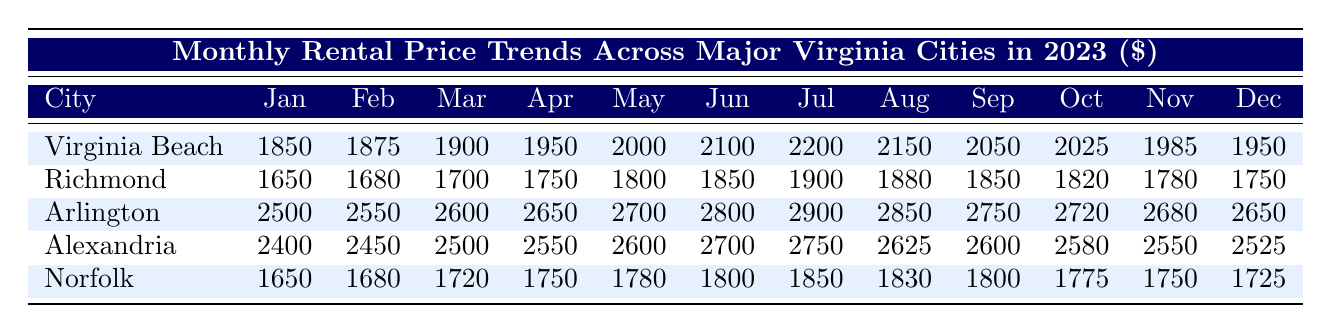What is the monthly rental price in Virginia Beach for June? The table provides the annual monthly rental prices for each city. In the row for Virginia Beach and under the column for June, the rental price is clearly listed as 2100.
Answer: 2100 What was the highest monthly rental price recorded in Arlington? In the Arlington row, the maximum monthly rental price is observed in July, where the value is listed as 2900.
Answer: 2900 Which city had the lowest rental price in January? Looking at the first column (January), the rental prices are 1850 for Virginia Beach, 1650 for Richmond, 2500 for Arlington, 2400 for Alexandria, and 1650 for Norfolk. The lowest price is 1650, which belongs to both Richmond and Norfolk.
Answer: 1650 What is the average monthly rental price for Norfolk over the year? To find the average, sum all the months for Norfolk: (1650 + 1680 + 1720 + 1750 + 1780 + 1800 + 1850 + 1830 + 1800 + 1775 + 1750 + 1725) = 20900. Dividing by the number of months (12), gives 20900/12 = 1741.67, which rounds to approximately 1742.
Answer: 1742 Is the rental price in Richmond higher than that in Virginia Beach in any month? By comparing the monthly figures, Richmond starts at 1650 and increases to a maximum of 1900 in July, while Virginia Beach starts at 1850 and climbs to a peak of 2200 in July. Richmond's price is lower than Virginia Beach's in all months.
Answer: No In which month did Alexandria's rental price reach its peak? Reviewing the Alexandria row, the price reaches its maximum of 2750 in July.
Answer: July What was the difference in rental prices between the highest month for Virginia Beach and the lowest month for Richmond? The highest rental price for Virginia Beach is 2200 in July, while the lowest for Richmond is 1650 in January. The difference is 2200 - 1650 = 550.
Answer: 550 How many months had a rental price greater than 2500 in Arlington? By counting those months in the Arlington row, the prices exceed 2500 in June (2800), July (2900), August (2850), September (2750), October (2720), November (2680), and December (2650). Total count is 7 months.
Answer: 7 Does the rental price trend in Virginia Beach show a clear upward pattern throughout the year? Analyzing the Virginia Beach prices month by month, all the values generally increase from January to July, peaking at 2200, followed by a slight decrease in the latter months, but the overall trend is likely still upwards due to initial increases.
Answer: Yes 